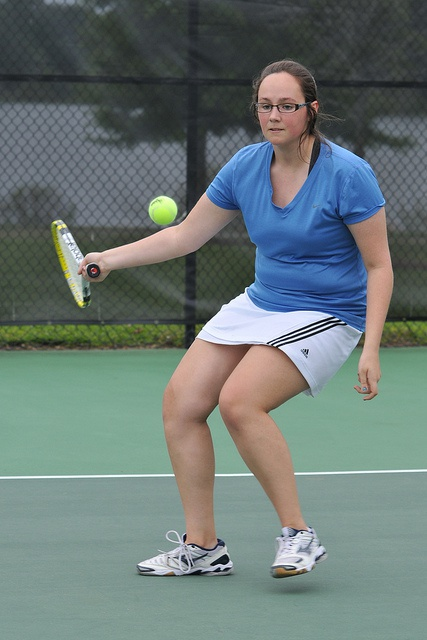Describe the objects in this image and their specific colors. I can see people in gray, blue, and darkgray tones, tennis racket in gray, darkgray, and lightgray tones, and sports ball in gray and lightgreen tones in this image. 